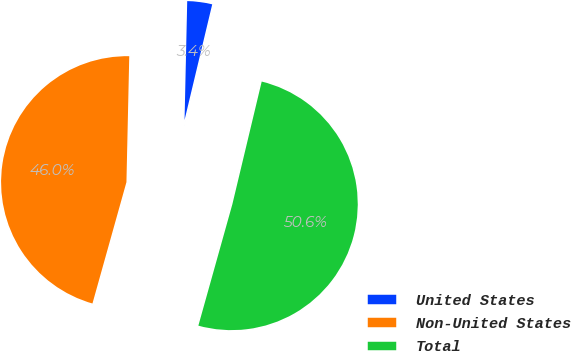<chart> <loc_0><loc_0><loc_500><loc_500><pie_chart><fcel>United States<fcel>Non-United States<fcel>Total<nl><fcel>3.38%<fcel>46.01%<fcel>50.61%<nl></chart> 